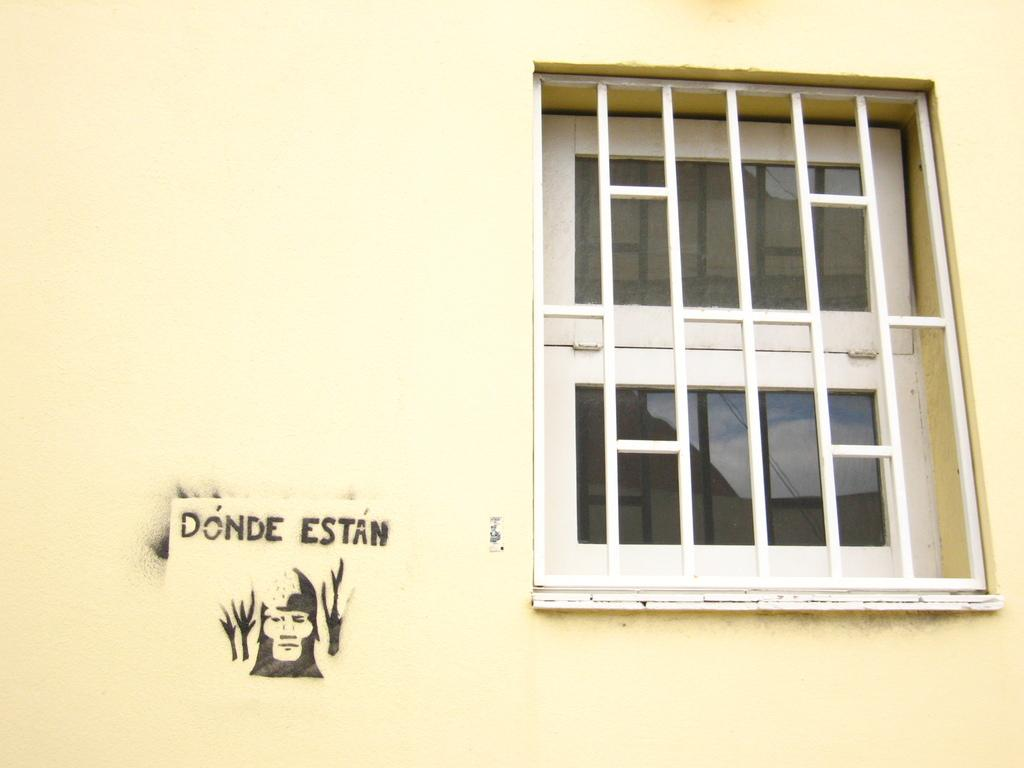Where was the image taken? The image was taken outdoors. What can be seen on the wall in the image? There is a wall in the image, and it has a window with grills. Is there any text visible on the wall? Yes, there is text on the wall in the image. How many jellyfish are swimming in the window of the image? There are no jellyfish present in the image; the window has grills and is not filled with water or marine life. 